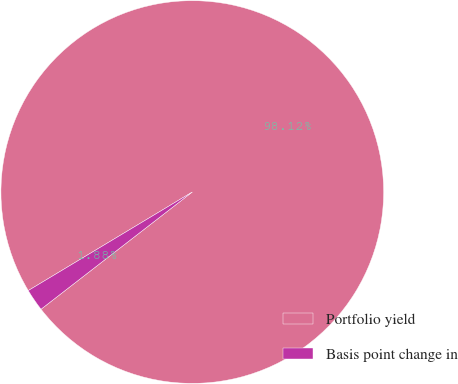Convert chart to OTSL. <chart><loc_0><loc_0><loc_500><loc_500><pie_chart><fcel>Portfolio yield<fcel>Basis point change in<nl><fcel>98.12%<fcel>1.88%<nl></chart> 